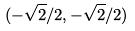<formula> <loc_0><loc_0><loc_500><loc_500>( - \sqrt { 2 } / 2 , - \sqrt { 2 } / 2 )</formula> 